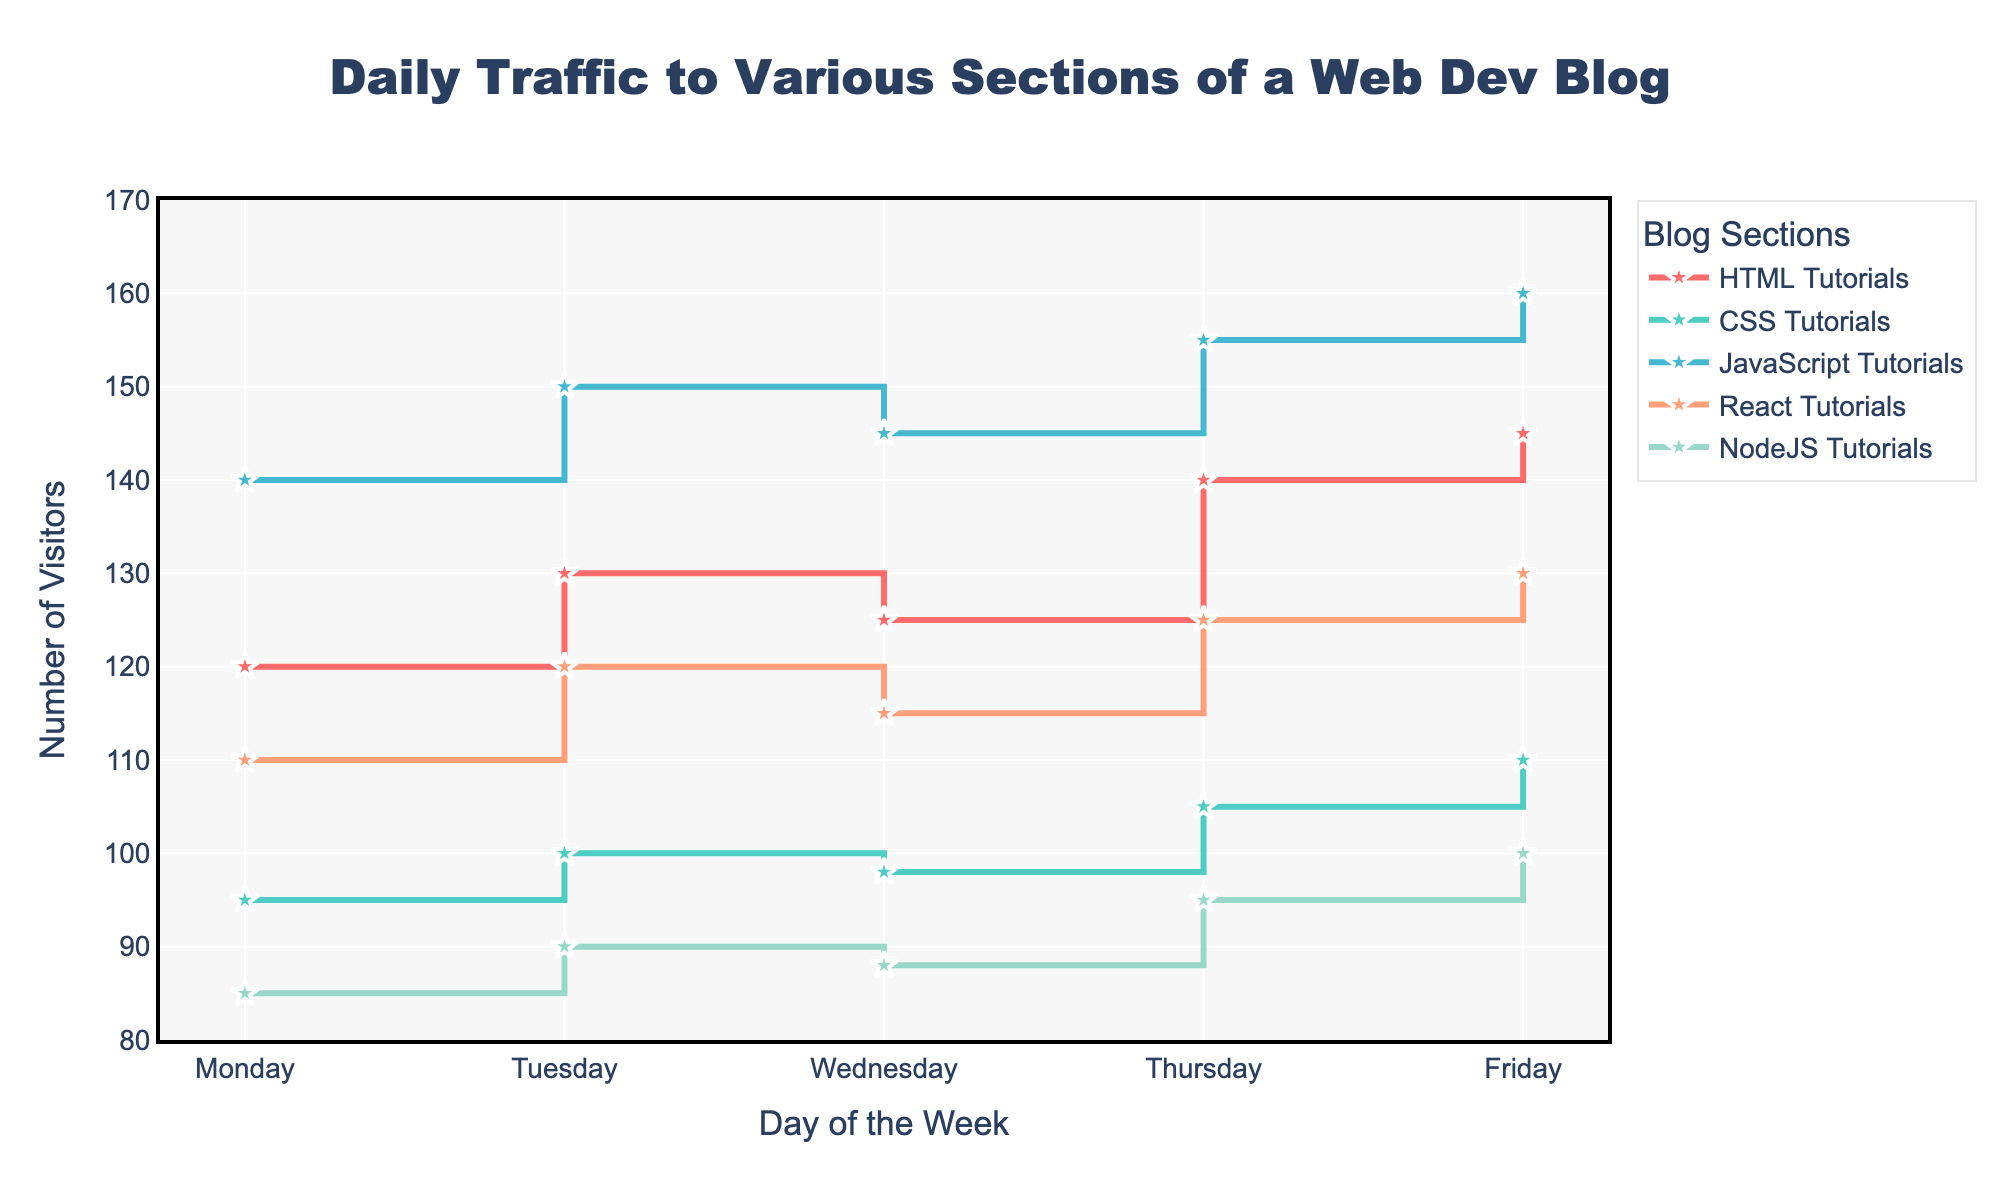What is the title of the chart? The title of the chart is displayed at the top and is 'Daily Traffic to Various Sections of a Web Dev Blog'.
Answer: 'Daily Traffic to Various Sections of a Web Dev Blog' What does the x-axis represent? The x-axis represents the days of the week, labeled as Monday, Tuesday, Wednesday, Thursday, and Friday.
Answer: Days of the week Which section had the highest traffic on Friday? By looking at the markers for Friday, the JavaScript Tutorials section had the highest traffic with 160 visitors.
Answer: JavaScript Tutorials What is the range of the y-axis? The y-axis is ranged from 80 to 170 visitors, as indicated by the axis labels.
Answer: 80 to 170 What color represents the HTML Tutorials section? The color representing the HTML Tutorials section is the first in the provided colors, which is a shade of red.
Answer: Red Which day had the lowest traffic for NodeJS Tutorials, and what was the value? By inspecting the stair steps for NodeJS Tutorials, Wednesday had the lowest traffic with 88 visitors.
Answer: Wednesday, 88 Comparing Monday and Tuesday, did traffic for React Tutorials increase or decrease? The traffic for React Tutorials increased from 110 on Monday to 120 on Tuesday.
Answer: Increase What is the average traffic for the CSS Tutorials section over the entire week? The traffic for CSS Tutorials over the week is 95, 100, 98, 105, and 110. Adding these and then dividing by 5, the average traffic is (95+100+98+105+110)/5 = 101.6, rounded to one decimal place.
Answer: 101.6 Which section had the most consistent traffic throughout the week? By analyzing the plot's stair steps, the NodeJS Tutorials section shows the least variance in the traffic levels, indicating it had the most consistent traffic.
Answer: NodeJS Tutorials How much more traffic did JavaScript Tutorials receive compared to CSS Tutorials on Thursday? On Thursday, JavaScript Tutorials received 155 visitors, while CSS Tutorials received 105. The difference is 155 - 105 = 50 visitors.
Answer: 50 